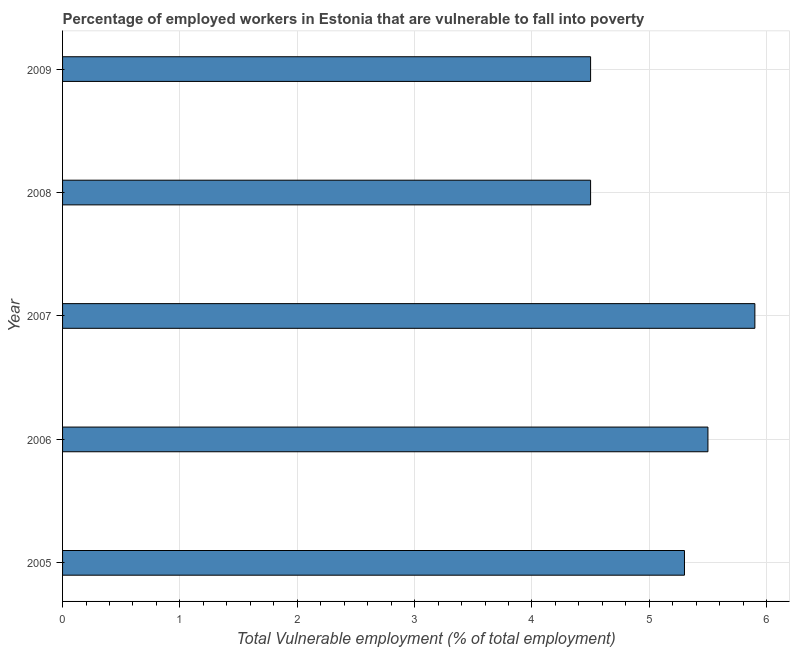Does the graph contain any zero values?
Provide a short and direct response. No. Does the graph contain grids?
Give a very brief answer. Yes. What is the title of the graph?
Keep it short and to the point. Percentage of employed workers in Estonia that are vulnerable to fall into poverty. What is the label or title of the X-axis?
Offer a terse response. Total Vulnerable employment (% of total employment). What is the label or title of the Y-axis?
Provide a short and direct response. Year. Across all years, what is the maximum total vulnerable employment?
Your answer should be compact. 5.9. Across all years, what is the minimum total vulnerable employment?
Provide a succinct answer. 4.5. In which year was the total vulnerable employment maximum?
Provide a succinct answer. 2007. What is the sum of the total vulnerable employment?
Offer a very short reply. 25.7. What is the average total vulnerable employment per year?
Give a very brief answer. 5.14. What is the median total vulnerable employment?
Your response must be concise. 5.3. What is the ratio of the total vulnerable employment in 2007 to that in 2009?
Your response must be concise. 1.31. Is the difference between the total vulnerable employment in 2006 and 2007 greater than the difference between any two years?
Keep it short and to the point. No. What is the difference between the highest and the second highest total vulnerable employment?
Keep it short and to the point. 0.4. Is the sum of the total vulnerable employment in 2007 and 2009 greater than the maximum total vulnerable employment across all years?
Keep it short and to the point. Yes. Are all the bars in the graph horizontal?
Offer a terse response. Yes. How many years are there in the graph?
Offer a terse response. 5. Are the values on the major ticks of X-axis written in scientific E-notation?
Keep it short and to the point. No. What is the Total Vulnerable employment (% of total employment) of 2005?
Make the answer very short. 5.3. What is the Total Vulnerable employment (% of total employment) in 2007?
Your response must be concise. 5.9. What is the Total Vulnerable employment (% of total employment) of 2008?
Your answer should be very brief. 4.5. What is the difference between the Total Vulnerable employment (% of total employment) in 2005 and 2006?
Provide a succinct answer. -0.2. What is the difference between the Total Vulnerable employment (% of total employment) in 2005 and 2008?
Keep it short and to the point. 0.8. What is the difference between the Total Vulnerable employment (% of total employment) in 2006 and 2008?
Offer a very short reply. 1. What is the difference between the Total Vulnerable employment (% of total employment) in 2007 and 2009?
Provide a short and direct response. 1.4. What is the difference between the Total Vulnerable employment (% of total employment) in 2008 and 2009?
Make the answer very short. 0. What is the ratio of the Total Vulnerable employment (% of total employment) in 2005 to that in 2006?
Provide a short and direct response. 0.96. What is the ratio of the Total Vulnerable employment (% of total employment) in 2005 to that in 2007?
Give a very brief answer. 0.9. What is the ratio of the Total Vulnerable employment (% of total employment) in 2005 to that in 2008?
Your answer should be compact. 1.18. What is the ratio of the Total Vulnerable employment (% of total employment) in 2005 to that in 2009?
Make the answer very short. 1.18. What is the ratio of the Total Vulnerable employment (% of total employment) in 2006 to that in 2007?
Keep it short and to the point. 0.93. What is the ratio of the Total Vulnerable employment (% of total employment) in 2006 to that in 2008?
Your answer should be very brief. 1.22. What is the ratio of the Total Vulnerable employment (% of total employment) in 2006 to that in 2009?
Give a very brief answer. 1.22. What is the ratio of the Total Vulnerable employment (% of total employment) in 2007 to that in 2008?
Keep it short and to the point. 1.31. What is the ratio of the Total Vulnerable employment (% of total employment) in 2007 to that in 2009?
Offer a terse response. 1.31. What is the ratio of the Total Vulnerable employment (% of total employment) in 2008 to that in 2009?
Your answer should be very brief. 1. 